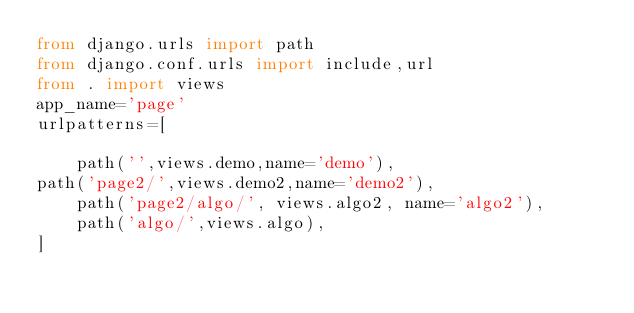Convert code to text. <code><loc_0><loc_0><loc_500><loc_500><_Python_>from django.urls import path
from django.conf.urls import include,url
from . import views
app_name='page'
urlpatterns=[

    path('',views.demo,name='demo'),
path('page2/',views.demo2,name='demo2'),
    path('page2/algo/', views.algo2, name='algo2'),
    path('algo/',views.algo),
]</code> 